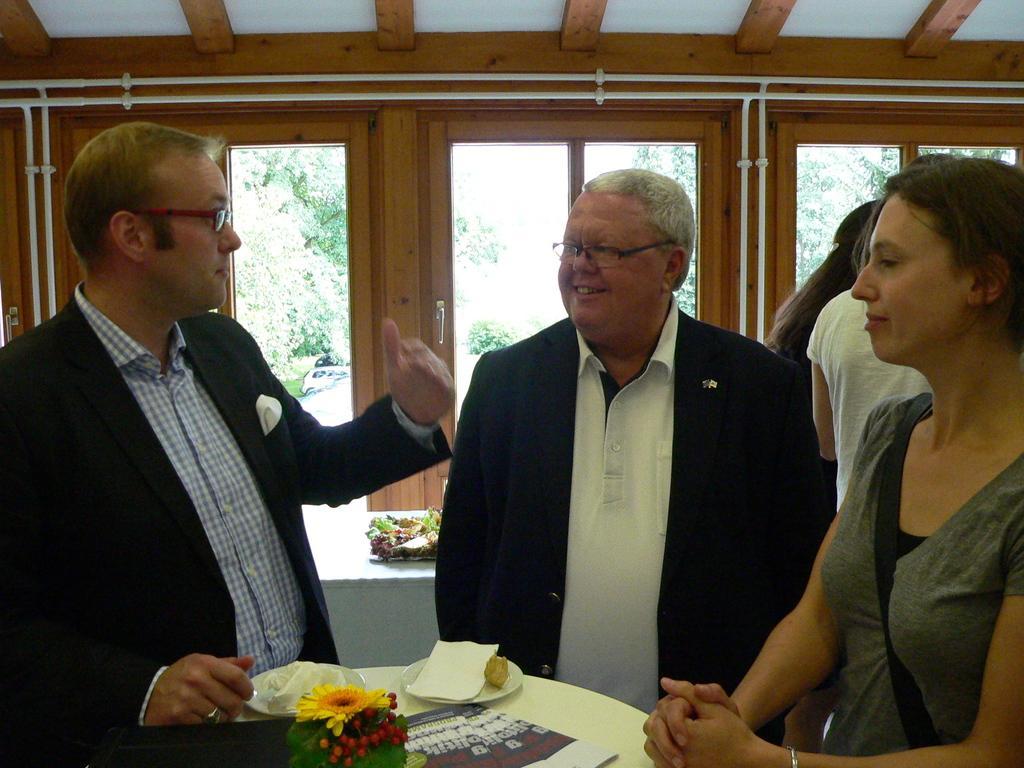In one or two sentences, can you explain what this image depicts? In-front of these people there is a table. On this table there are plates, flowers and objects. Through this glass windows we can see trees and vehicle.  